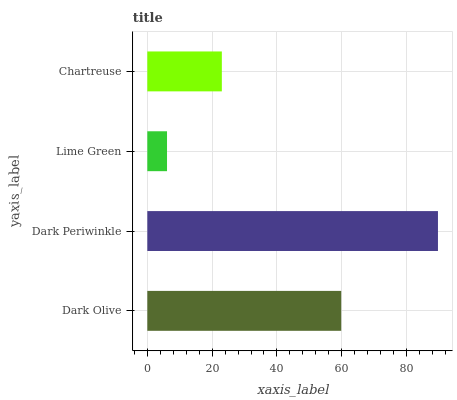Is Lime Green the minimum?
Answer yes or no. Yes. Is Dark Periwinkle the maximum?
Answer yes or no. Yes. Is Dark Periwinkle the minimum?
Answer yes or no. No. Is Lime Green the maximum?
Answer yes or no. No. Is Dark Periwinkle greater than Lime Green?
Answer yes or no. Yes. Is Lime Green less than Dark Periwinkle?
Answer yes or no. Yes. Is Lime Green greater than Dark Periwinkle?
Answer yes or no. No. Is Dark Periwinkle less than Lime Green?
Answer yes or no. No. Is Dark Olive the high median?
Answer yes or no. Yes. Is Chartreuse the low median?
Answer yes or no. Yes. Is Lime Green the high median?
Answer yes or no. No. Is Lime Green the low median?
Answer yes or no. No. 